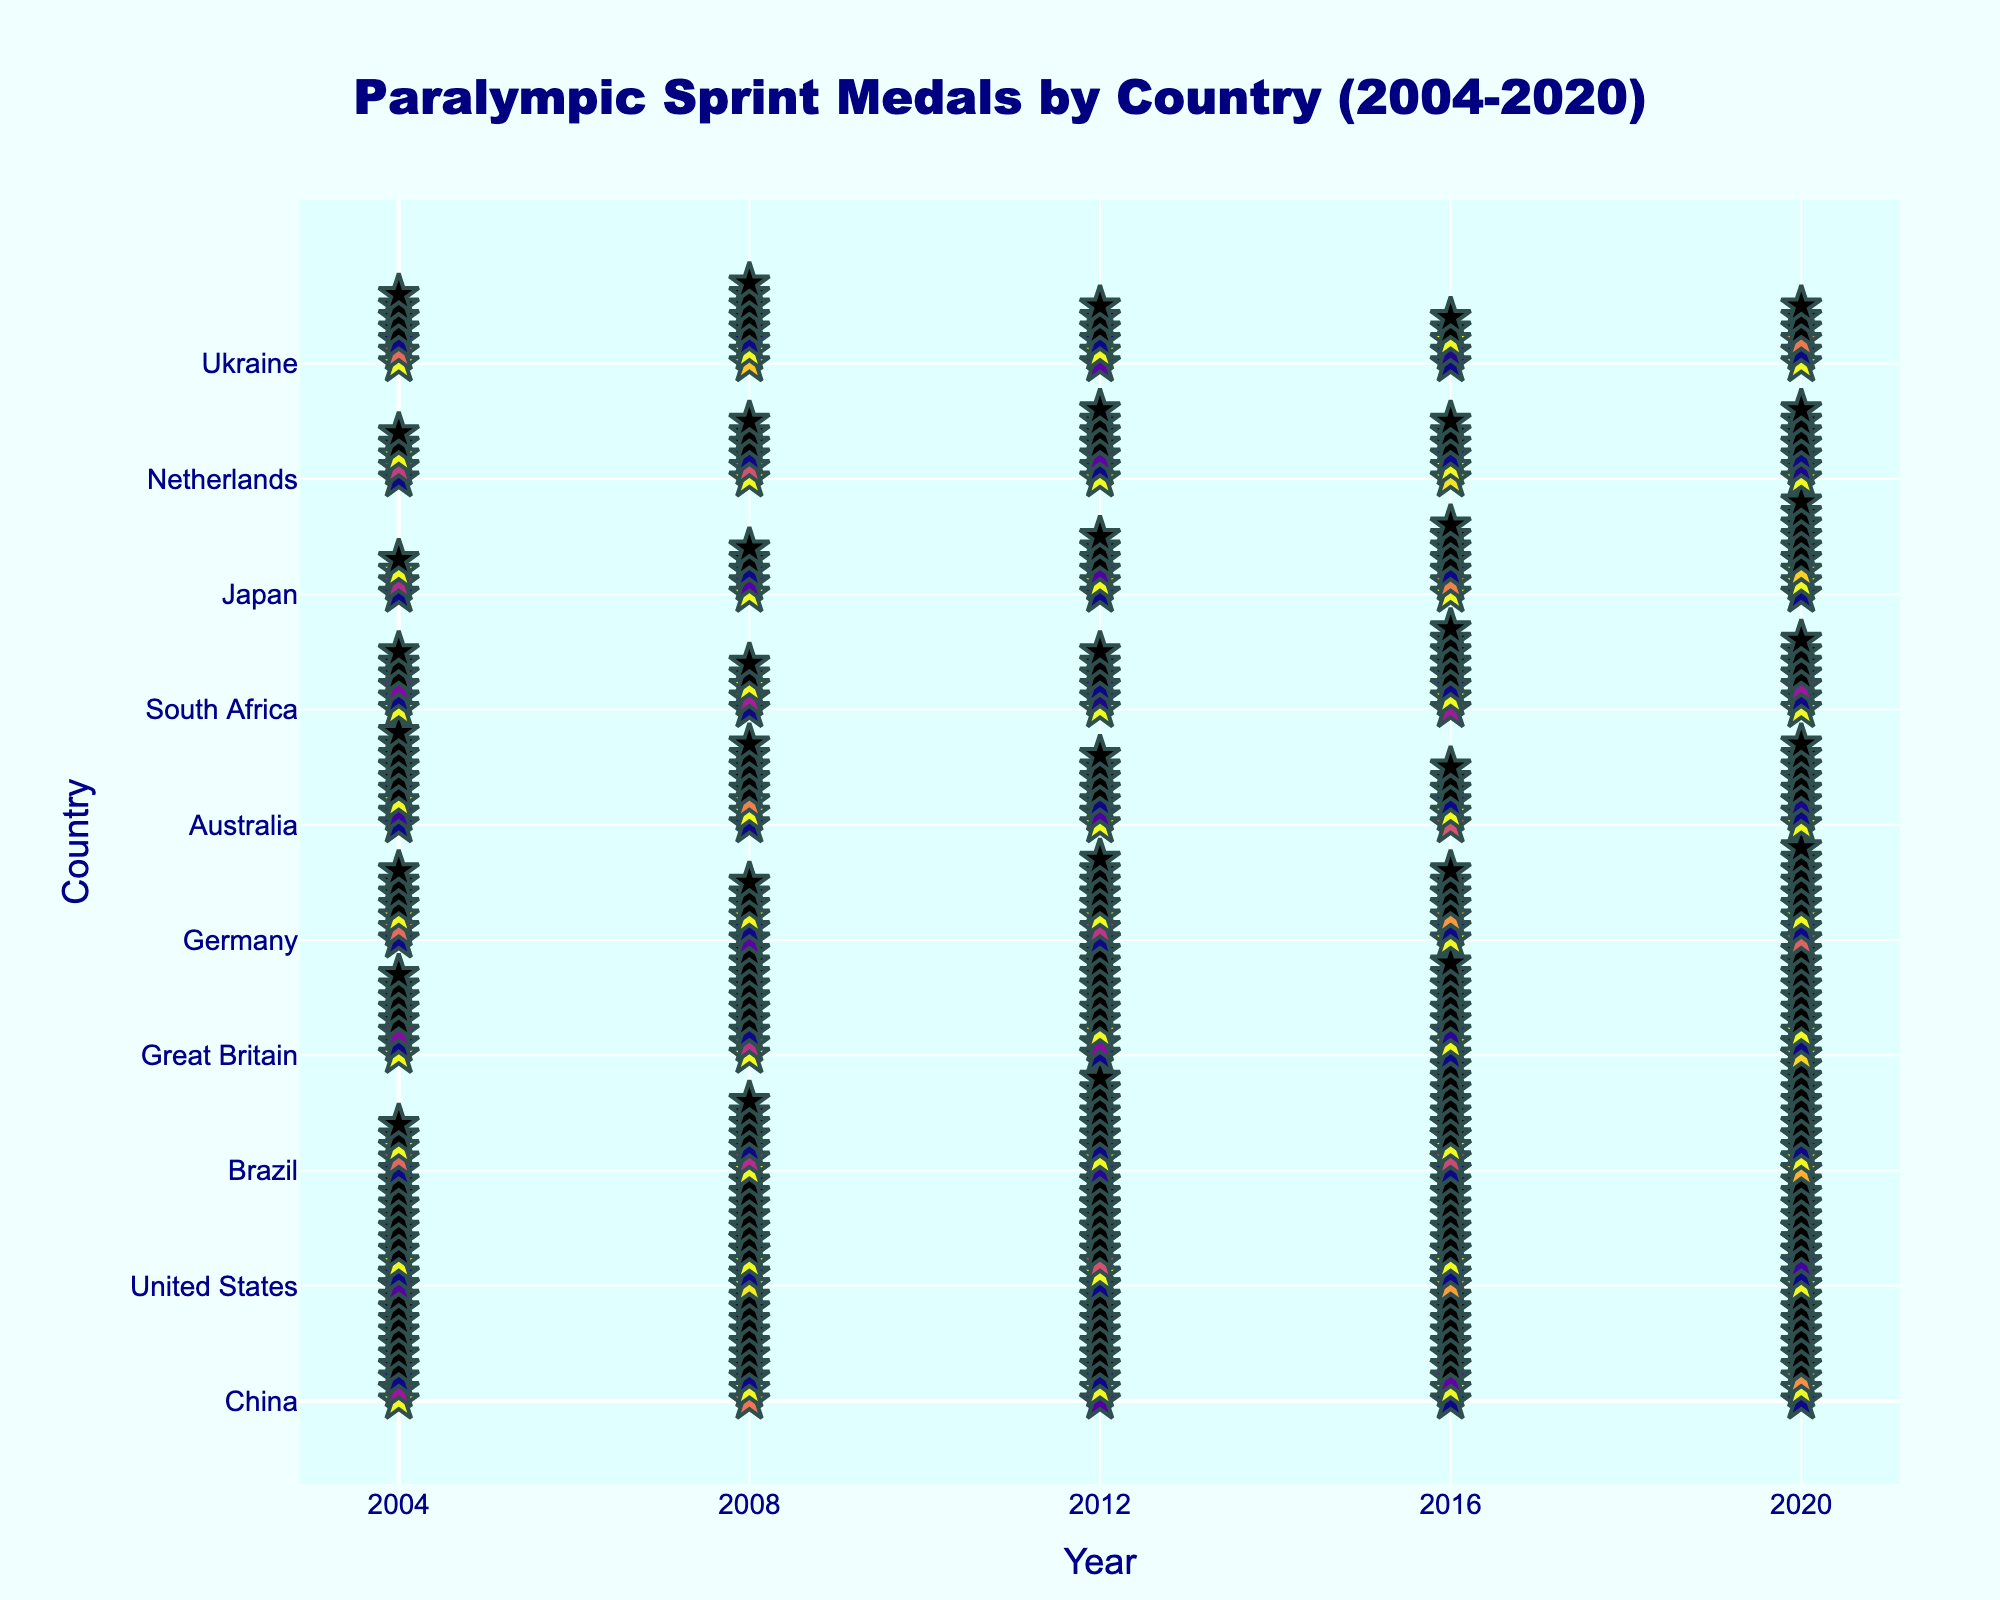What is the title of the figure? The title of the figure is usually placed at the top and provides a summary of the data being visualized. By looking at the top of the figure, we can see "Paralympic Sprint Medals by Country (2004-2020)".
Answer: Paralympic Sprint Medals by Country (2004-2020) Which country won the most medals in 2020? To find the country with the most medals in 2020, look at the column labeled 2020 and identify the highest number of stars. China has 16 stars.
Answer: China How many medals did Brazil win in total from 2004 to 2020? Sum the number of medals Brazil won in each year: 5 (2004) + 7 (2008) + 9 (2012) + 10 (2016) + 12 (2020) = 43.
Answer: 43 Which country had the biggest decrease in medals from 2008 to 2016? Subtract the number of medals in 2016 from the number in 2008 for each country and find the largest negative difference. For USA: 15 (2016) - 11 (2008) = +4. For Australia: 6 (2016) - 8 (2008) = -2 (biggest decrease).
Answer: Australia What is the average number of medals won by Japan across all the years? Sum the number of medals Japan won each year and divide by the total number of years: (4 + 5 + 6 + 7 + 9) / 5 = 31 / 5 = 6.2.
Answer: 6.2 Did any country have consistent medal counts over two consecutive Games? Check if any country has the same number of medals in two consecutive years. Netherlands had 6 medals in both 2008 and 2016, USA had 13 medals in both 2012 and 2016.
Answer: Yes, Netherlands and USA Which country has the most consistent performance over the five Games? Find the country with the smallest variance in medal counts across the five Games. Calculate the variance for each. For Germany: (7, 6, 8, 7, 9) has the smallest spread.
Answer: Germany What year did Great Britain win the highest number of medals? Look at the row for Great Britain and find the year with the most stars. Great Britain won 11 medals in 2012 and 2020.
Answer: 2012 and 2020 How do the medal counts for China and the United States compare over the span of the five Games? Look at the rows for China and the United States across all years, compare year by year. China generally has higher counts except in 2016 where USA had 15 vs China's 14.
Answer: China generally higher Which countries showed improvement in medal counts in every Game from 2008 to 2020? Check the trend for each country to see if there's a year-over-year increase. Brazil shows consistent increase (7, 9, 10, 12), and Japan (5, 6, 7, 9) from 2008-2020.
Answer: Brazil and Japan 